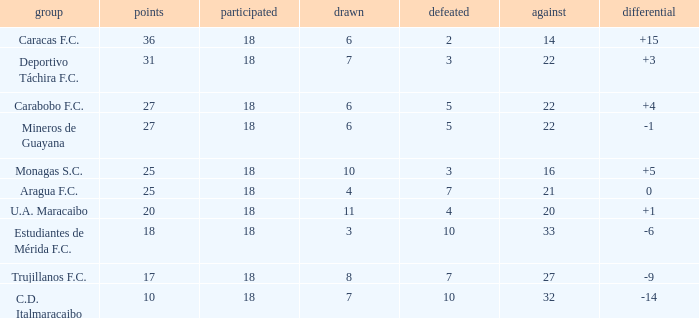What is the aggregate score of teams with against scores less than 14 points? None. 